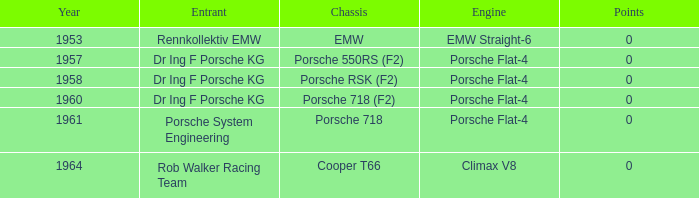What chassis was utilized by the porsche flat-4 prior to 1958? Porsche 550RS (F2). 